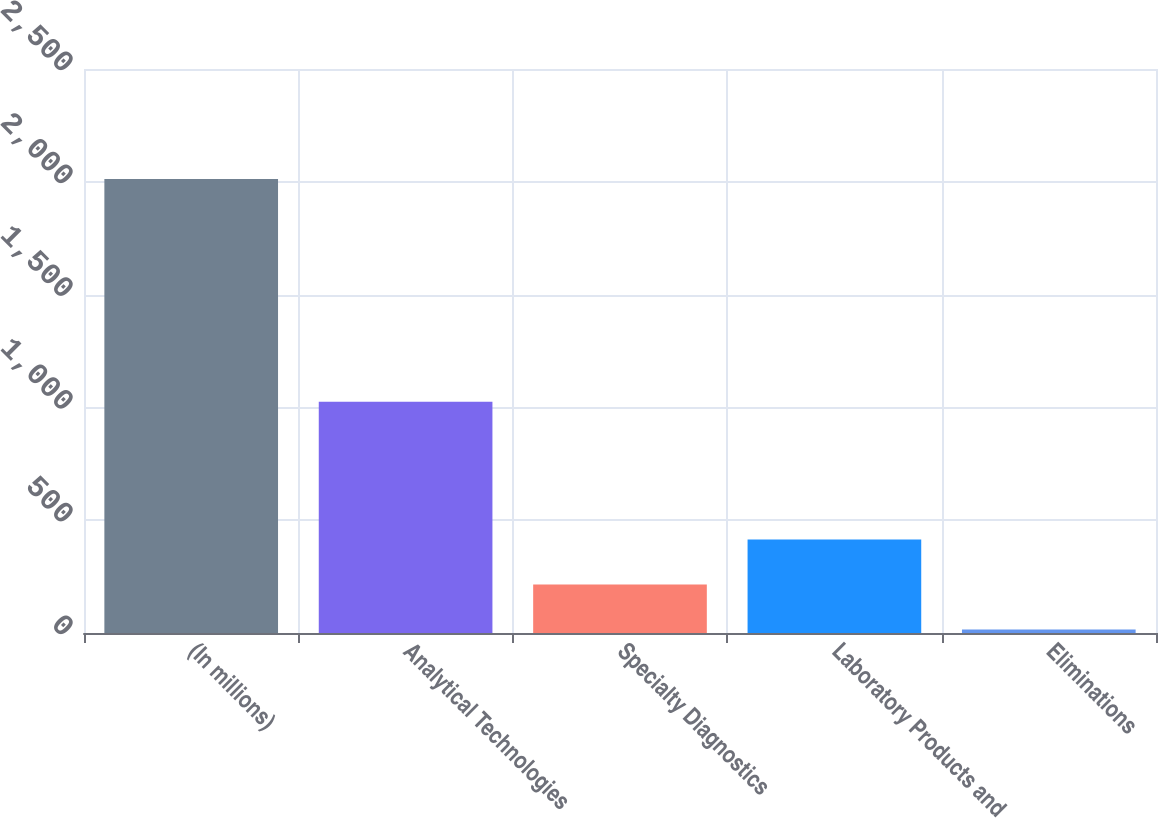<chart> <loc_0><loc_0><loc_500><loc_500><bar_chart><fcel>(In millions)<fcel>Analytical Technologies<fcel>Specialty Diagnostics<fcel>Laboratory Products and<fcel>Eliminations<nl><fcel>2012<fcel>1025<fcel>215.06<fcel>414.72<fcel>15.4<nl></chart> 